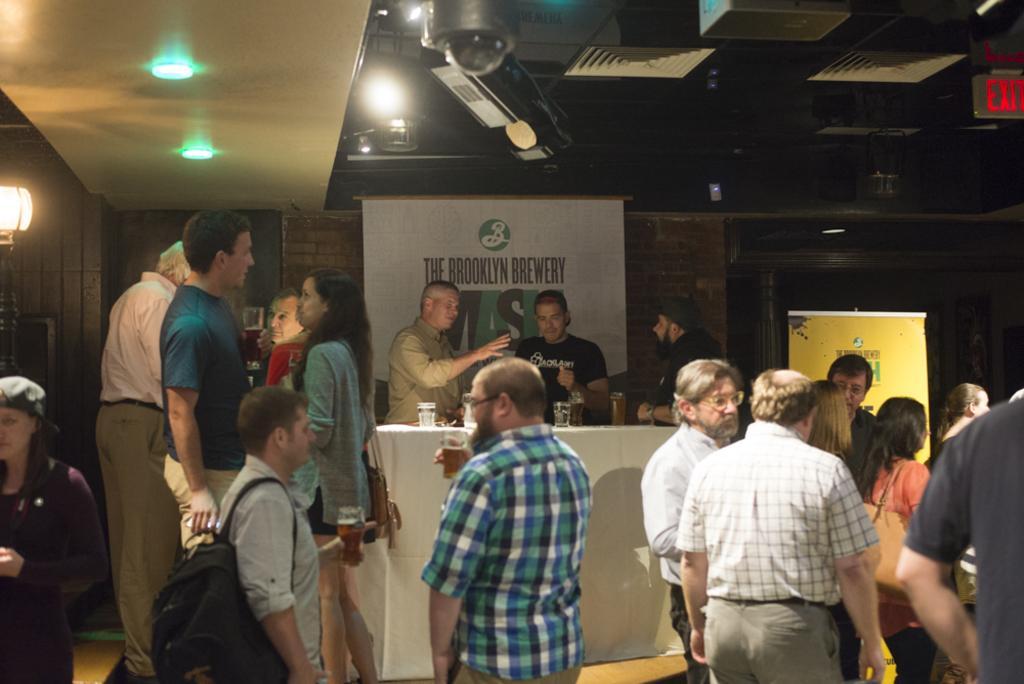Describe this image in one or two sentences. In the image there are many people standing. There are few people with glasses in their hands. And also there is a table with glasses. In the background there is a wall with banners. At the top of the image there is a ceiling with lights. And on the right side of the image there is a sign board. And on the left side of the image there is a lamp. 